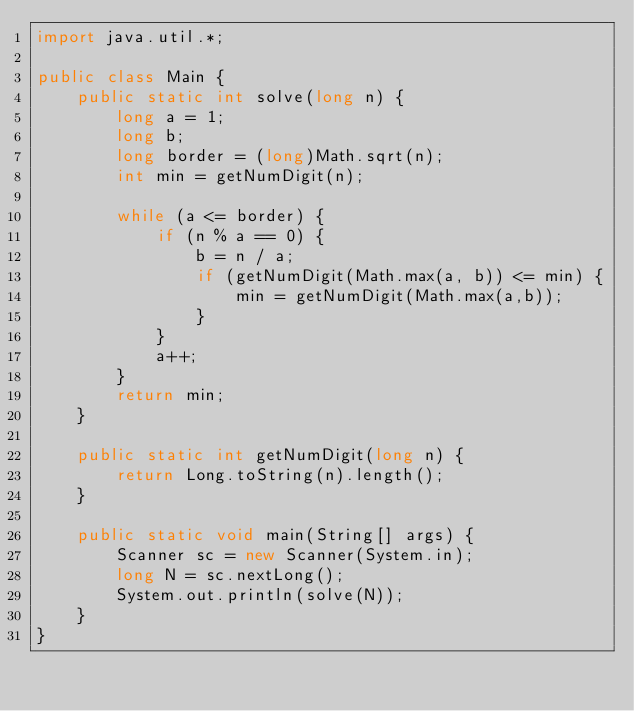<code> <loc_0><loc_0><loc_500><loc_500><_Java_>import java.util.*;

public class Main {
    public static int solve(long n) {
        long a = 1;
        long b;
        long border = (long)Math.sqrt(n);
        int min = getNumDigit(n);

        while (a <= border) {
            if (n % a == 0) {
                b = n / a;
                if (getNumDigit(Math.max(a, b)) <= min) {
                    min = getNumDigit(Math.max(a,b));
                }
            }
            a++;
        }
        return min;
    }

    public static int getNumDigit(long n) {
        return Long.toString(n).length();
    }

    public static void main(String[] args) {
        Scanner sc = new Scanner(System.in);
        long N = sc.nextLong();
        System.out.println(solve(N));
    }
}
</code> 